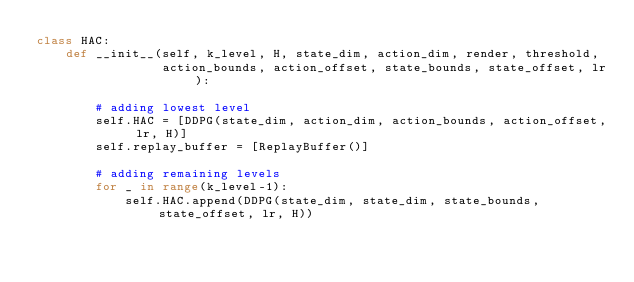<code> <loc_0><loc_0><loc_500><loc_500><_Python_>class HAC:
    def __init__(self, k_level, H, state_dim, action_dim, render, threshold, 
                 action_bounds, action_offset, state_bounds, state_offset, lr):
        
        # adding lowest level
        self.HAC = [DDPG(state_dim, action_dim, action_bounds, action_offset, lr, H)]
        self.replay_buffer = [ReplayBuffer()]
        
        # adding remaining levels
        for _ in range(k_level-1):
            self.HAC.append(DDPG(state_dim, state_dim, state_bounds, state_offset, lr, H))</code> 